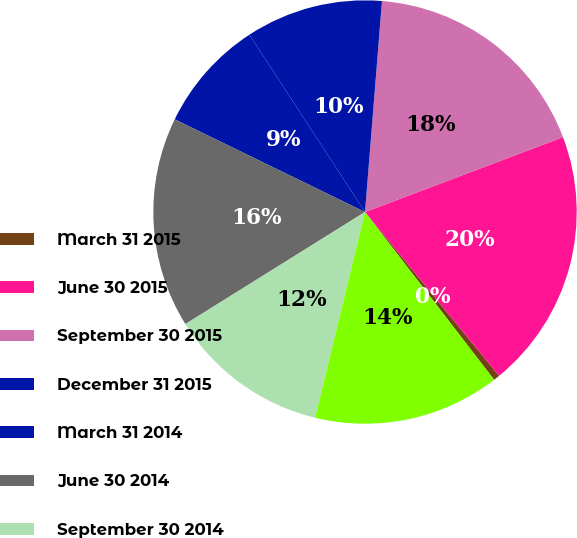Convert chart. <chart><loc_0><loc_0><loc_500><loc_500><pie_chart><fcel>March 31 2015<fcel>June 30 2015<fcel>September 30 2015<fcel>December 31 2015<fcel>March 31 2014<fcel>June 30 2014<fcel>September 30 2014<fcel>December 31 2014<nl><fcel>0.47%<fcel>19.84%<fcel>17.97%<fcel>10.47%<fcel>8.59%<fcel>16.09%<fcel>12.34%<fcel>14.22%<nl></chart> 